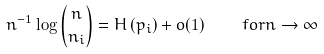Convert formula to latex. <formula><loc_0><loc_0><loc_500><loc_500>n ^ { - 1 } \log { n \choose n _ { i } } = H \left ( p _ { i } \right ) + o ( 1 ) \quad f o r n \rightarrow \infty</formula> 